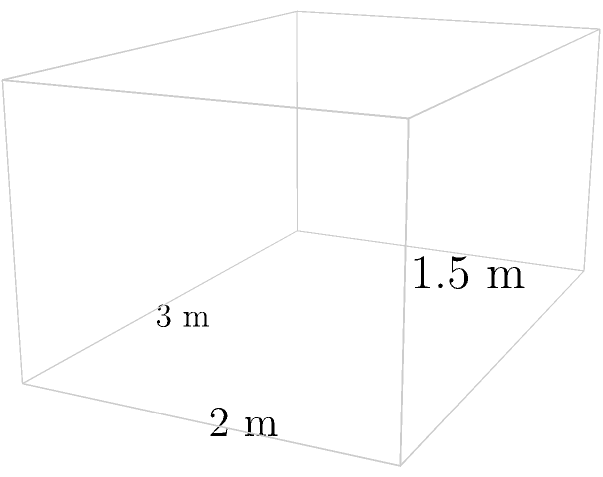As a restaurateur collaborating with food truck owners, you're designing a custom refrigerator for a mobile kitchen. The refrigerator is a cuboid with dimensions 3 m length, 2 m width, and 1.5 m height. Calculate the total surface area of the refrigerator to determine the amount of insulating material needed. To calculate the total surface area of a cuboid refrigerator, we need to sum up the areas of all six faces. Let's break it down step by step:

1. Identify the dimensions:
   Length (l) = 3 m
   Width (w) = 2 m
   Height (h) = 1.5 m

2. Calculate the area of each pair of faces:
   a) Front and back faces: $A_1 = 2 \times (w \times h) = 2 \times (2 \times 1.5) = 6$ m²
   b) Left and right faces: $A_2 = 2 \times (l \times h) = 2 \times (3 \times 1.5) = 9$ m²
   c) Top and bottom faces: $A_3 = 2 \times (l \times w) = 2 \times (3 \times 2) = 12$ m²

3. Sum up all the areas:
   Total Surface Area = $A_1 + A_2 + A_3 = 6 + 9 + 12 = 27$ m²

Therefore, the total surface area of the cuboid refrigerator is 27 square meters.
Answer: 27 m² 